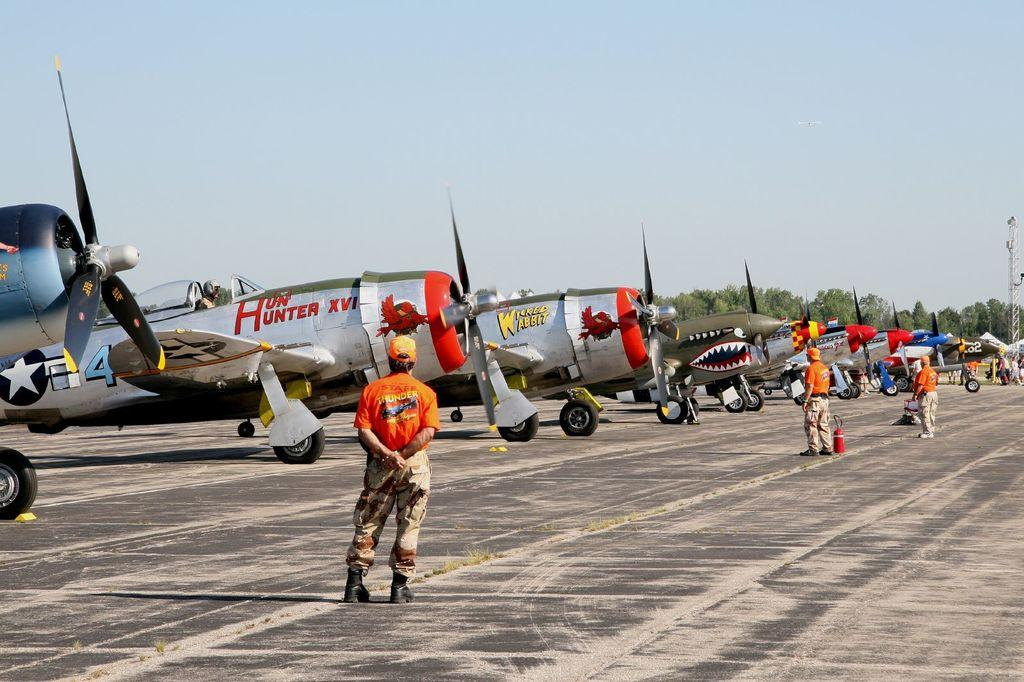<image>
Write a terse but informative summary of the picture. Hun Hunter XVI plane parked in a line next to other planes. 